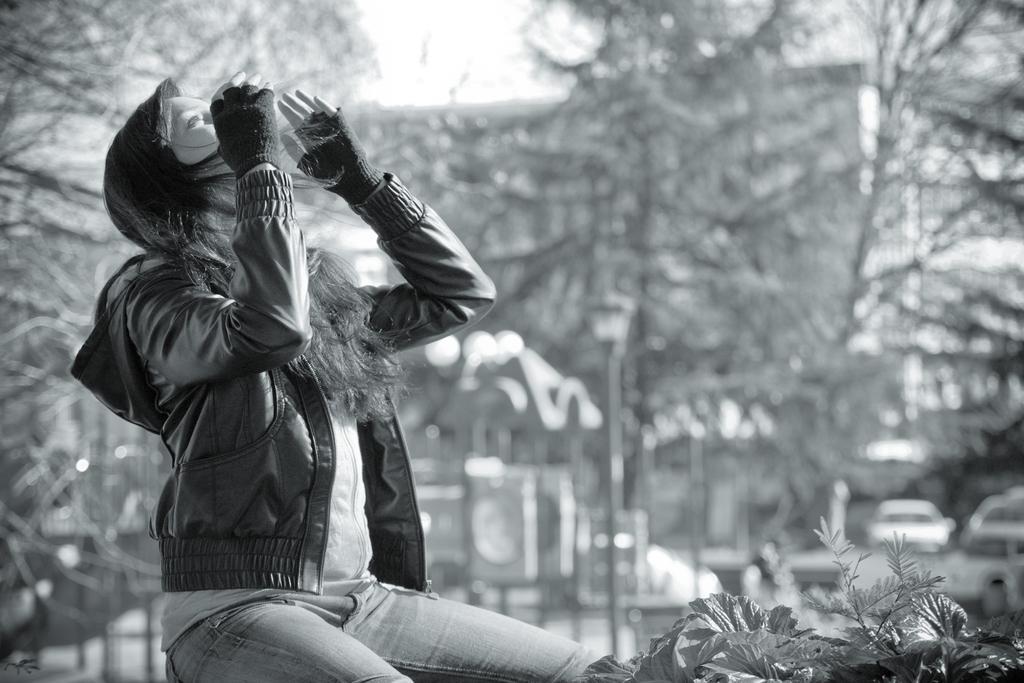How would you summarize this image in a sentence or two? In the foreground of this black and white image, on the left, there is a woman sitting and at the bottom, there are plants. In the background, there are trees, building, few vehicles and the sky. 